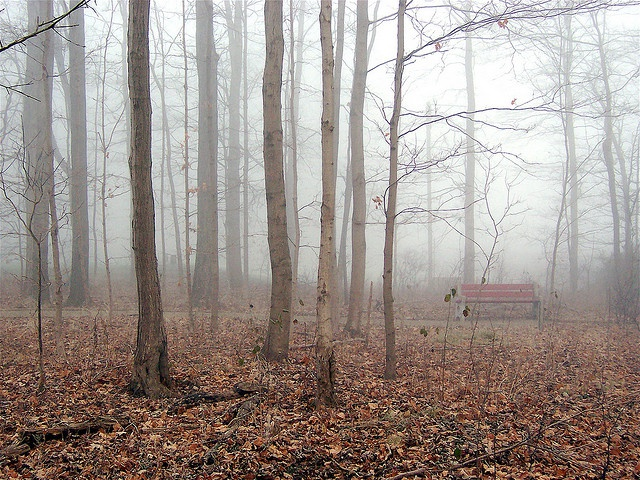Describe the objects in this image and their specific colors. I can see a bench in white and gray tones in this image. 